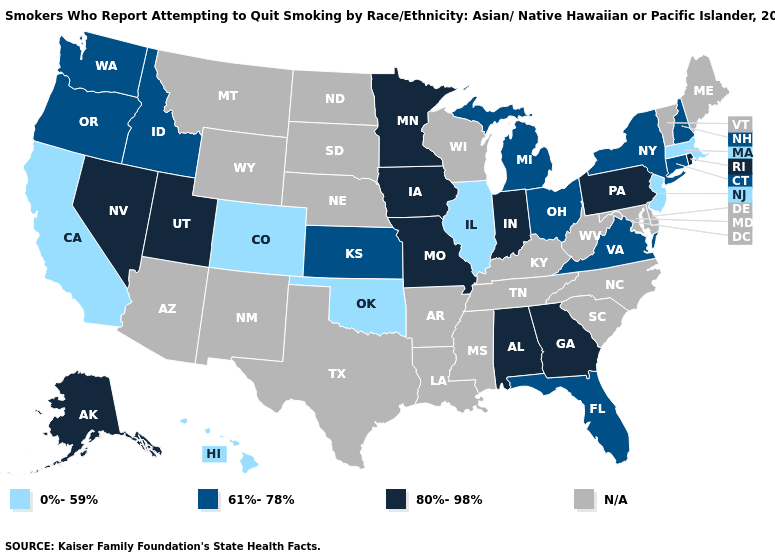Among the states that border Indiana , does Illinois have the highest value?
Keep it brief. No. Does Ohio have the lowest value in the USA?
Concise answer only. No. Which states hav the highest value in the West?
Be succinct. Alaska, Nevada, Utah. What is the value of South Dakota?
Concise answer only. N/A. What is the highest value in the South ?
Write a very short answer. 80%-98%. Does the map have missing data?
Be succinct. Yes. Name the states that have a value in the range N/A?
Answer briefly. Arizona, Arkansas, Delaware, Kentucky, Louisiana, Maine, Maryland, Mississippi, Montana, Nebraska, New Mexico, North Carolina, North Dakota, South Carolina, South Dakota, Tennessee, Texas, Vermont, West Virginia, Wisconsin, Wyoming. Among the states that border New Mexico , which have the highest value?
Give a very brief answer. Utah. What is the value of South Dakota?
Answer briefly. N/A. Name the states that have a value in the range 0%-59%?
Answer briefly. California, Colorado, Hawaii, Illinois, Massachusetts, New Jersey, Oklahoma. Name the states that have a value in the range 61%-78%?
Keep it brief. Connecticut, Florida, Idaho, Kansas, Michigan, New Hampshire, New York, Ohio, Oregon, Virginia, Washington. Name the states that have a value in the range N/A?
Be succinct. Arizona, Arkansas, Delaware, Kentucky, Louisiana, Maine, Maryland, Mississippi, Montana, Nebraska, New Mexico, North Carolina, North Dakota, South Carolina, South Dakota, Tennessee, Texas, Vermont, West Virginia, Wisconsin, Wyoming. Does Oklahoma have the highest value in the USA?
Short answer required. No. What is the highest value in the USA?
Give a very brief answer. 80%-98%. 